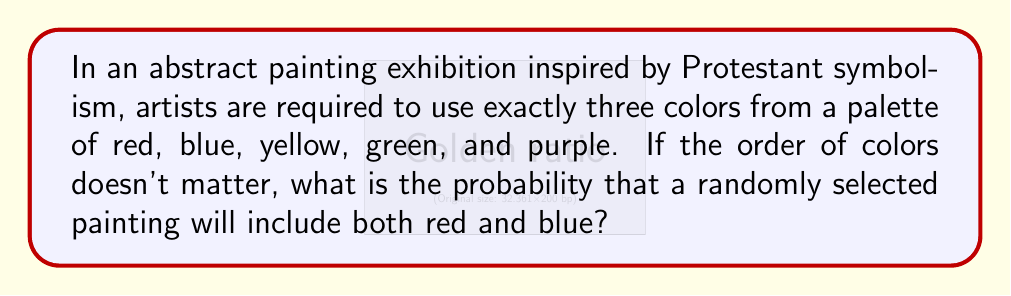Teach me how to tackle this problem. Let's approach this step-by-step:

1) First, we need to calculate the total number of possible color combinations. This is a combination problem where we choose 3 colors from 5 without repetition and where order doesn't matter. We can represent this as:

   $$\binom{5}{3} = \frac{5!}{3!(5-3)!} = \frac{5 \cdot 4 \cdot 3}{3 \cdot 2 \cdot 1} = 10$$

2) Now, we need to find the number of combinations that include both red and blue. If red and blue are already chosen, we need to select one more color from the remaining three (yellow, green, purple). This can be represented as:

   $$\binom{3}{1} = 3$$

3) To calculate the probability, we divide the favorable outcomes by the total outcomes:

   $$P(\text{red and blue}) = \frac{\text{combinations with red and blue}}{\text{total combinations}} = \frac{3}{10}$$

4) We can simplify this fraction:

   $$\frac{3}{10} = 0.3$$

Therefore, the probability of a randomly selected painting including both red and blue is 0.3 or 30%.
Answer: $\frac{3}{10}$ or 0.3 or 30% 